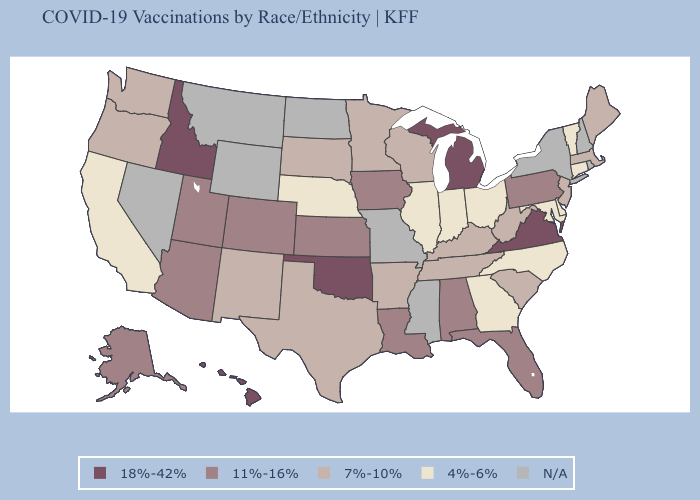What is the value of Florida?
Be succinct. 11%-16%. Which states have the lowest value in the South?
Answer briefly. Delaware, Georgia, Maryland, North Carolina. What is the value of Connecticut?
Be succinct. 4%-6%. Among the states that border Montana , which have the highest value?
Give a very brief answer. Idaho. Among the states that border Mississippi , which have the highest value?
Write a very short answer. Alabama, Louisiana. Is the legend a continuous bar?
Keep it brief. No. What is the value of Louisiana?
Short answer required. 11%-16%. Name the states that have a value in the range 11%-16%?
Be succinct. Alabama, Alaska, Arizona, Colorado, Florida, Iowa, Kansas, Louisiana, Pennsylvania, Utah. What is the lowest value in the West?
Quick response, please. 4%-6%. Name the states that have a value in the range 4%-6%?
Short answer required. California, Connecticut, Delaware, Georgia, Illinois, Indiana, Maryland, Nebraska, North Carolina, Ohio, Vermont. Does Idaho have the highest value in the USA?
Keep it brief. Yes. Name the states that have a value in the range N/A?
Be succinct. Mississippi, Missouri, Montana, Nevada, New Hampshire, New York, North Dakota, Rhode Island, Wyoming. What is the value of Wisconsin?
Keep it brief. 7%-10%. Name the states that have a value in the range N/A?
Short answer required. Mississippi, Missouri, Montana, Nevada, New Hampshire, New York, North Dakota, Rhode Island, Wyoming. Name the states that have a value in the range 11%-16%?
Quick response, please. Alabama, Alaska, Arizona, Colorado, Florida, Iowa, Kansas, Louisiana, Pennsylvania, Utah. 